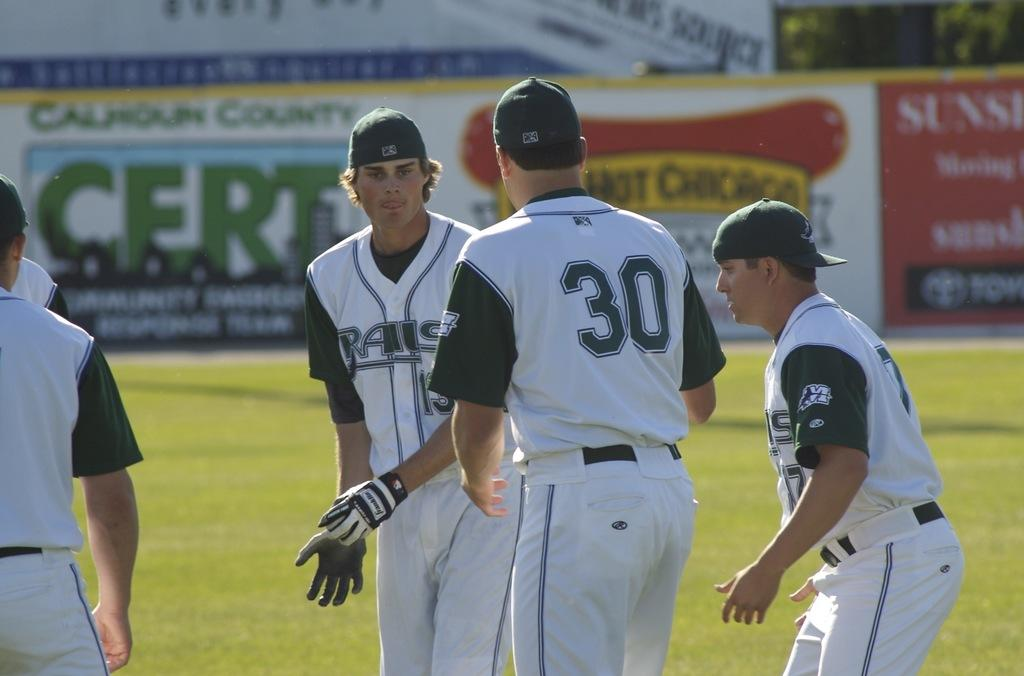Provide a one-sentence caption for the provided image. a player with the number 30 on his back. 